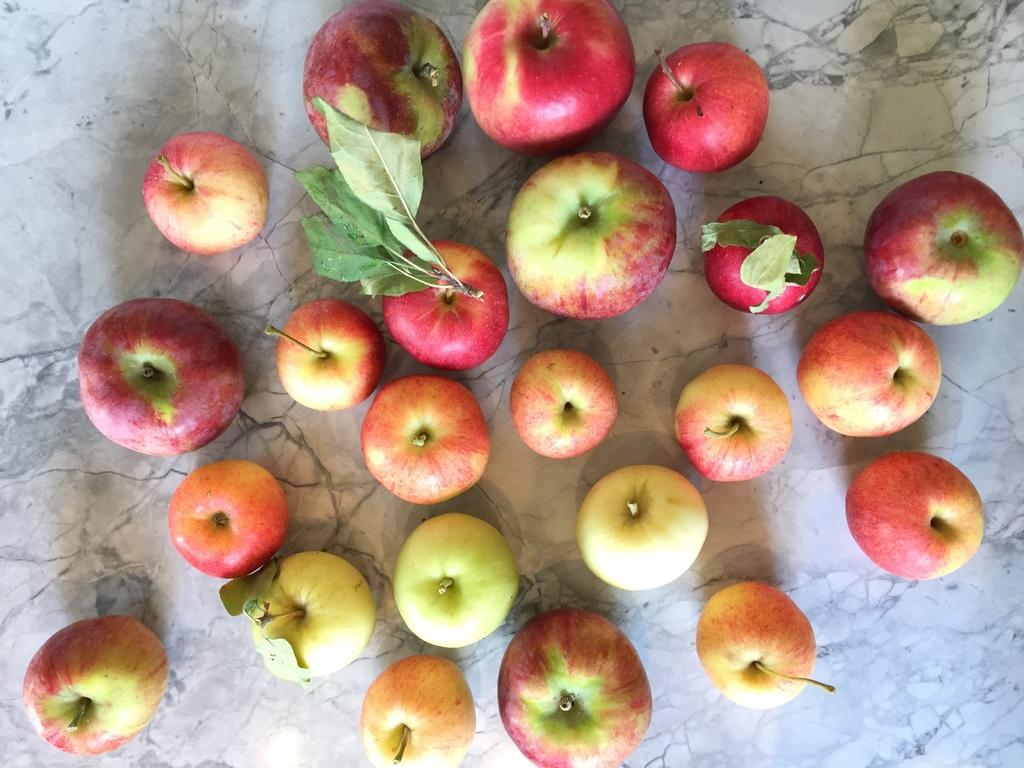What objects are on the floor in the image? There are apples on the floor in the image. Where is the throne located in the image? There is no throne present in the image. What type of trees can be seen in the image? There are no trees present in the image. What material is the floor made of in the image? The material of the floor is not mentioned in the image, so it cannot be determined. 